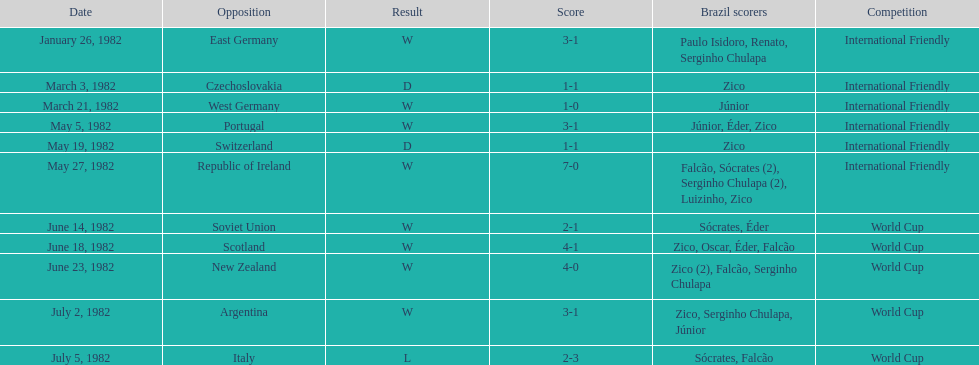Who was this team's next opponent after facing the soviet union on june 14? Scotland. 